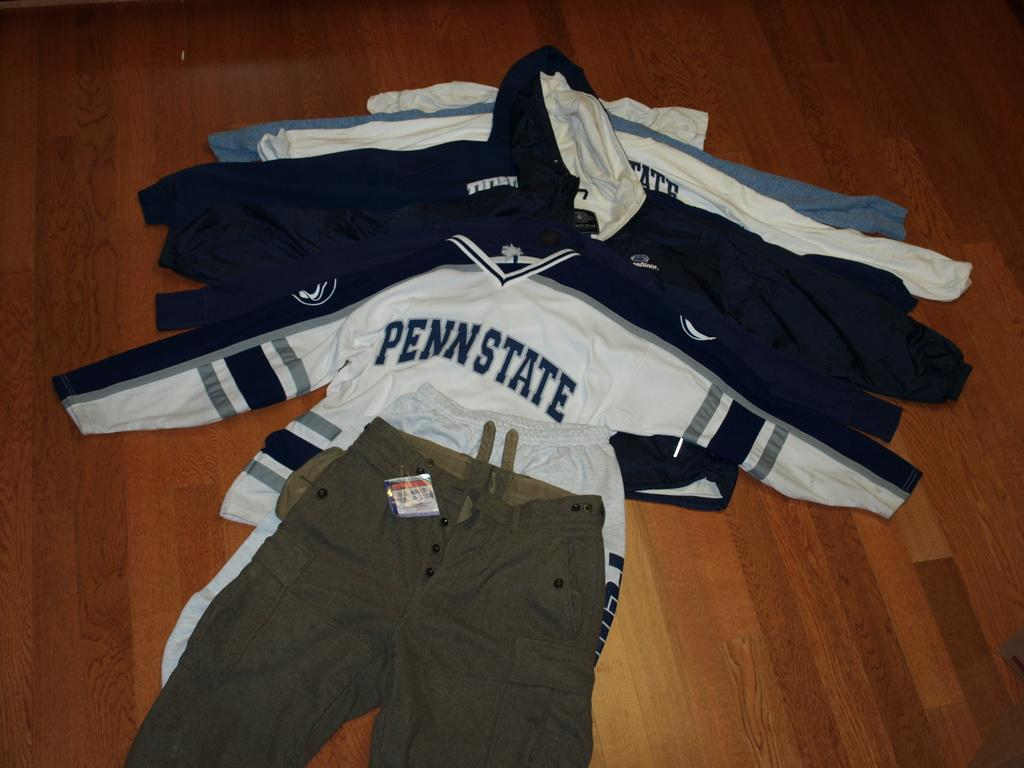What type of clothing items can be seen in the image? There are t-shirts and pants in the image. Where are the t-shirts and pants located? The t-shirts and pants are on a wooden floor. What type of cord is being used to hang the t-shirts in the image? There is no cord present in the image; the t-shirts and pants are simply placed on the wooden floor. 